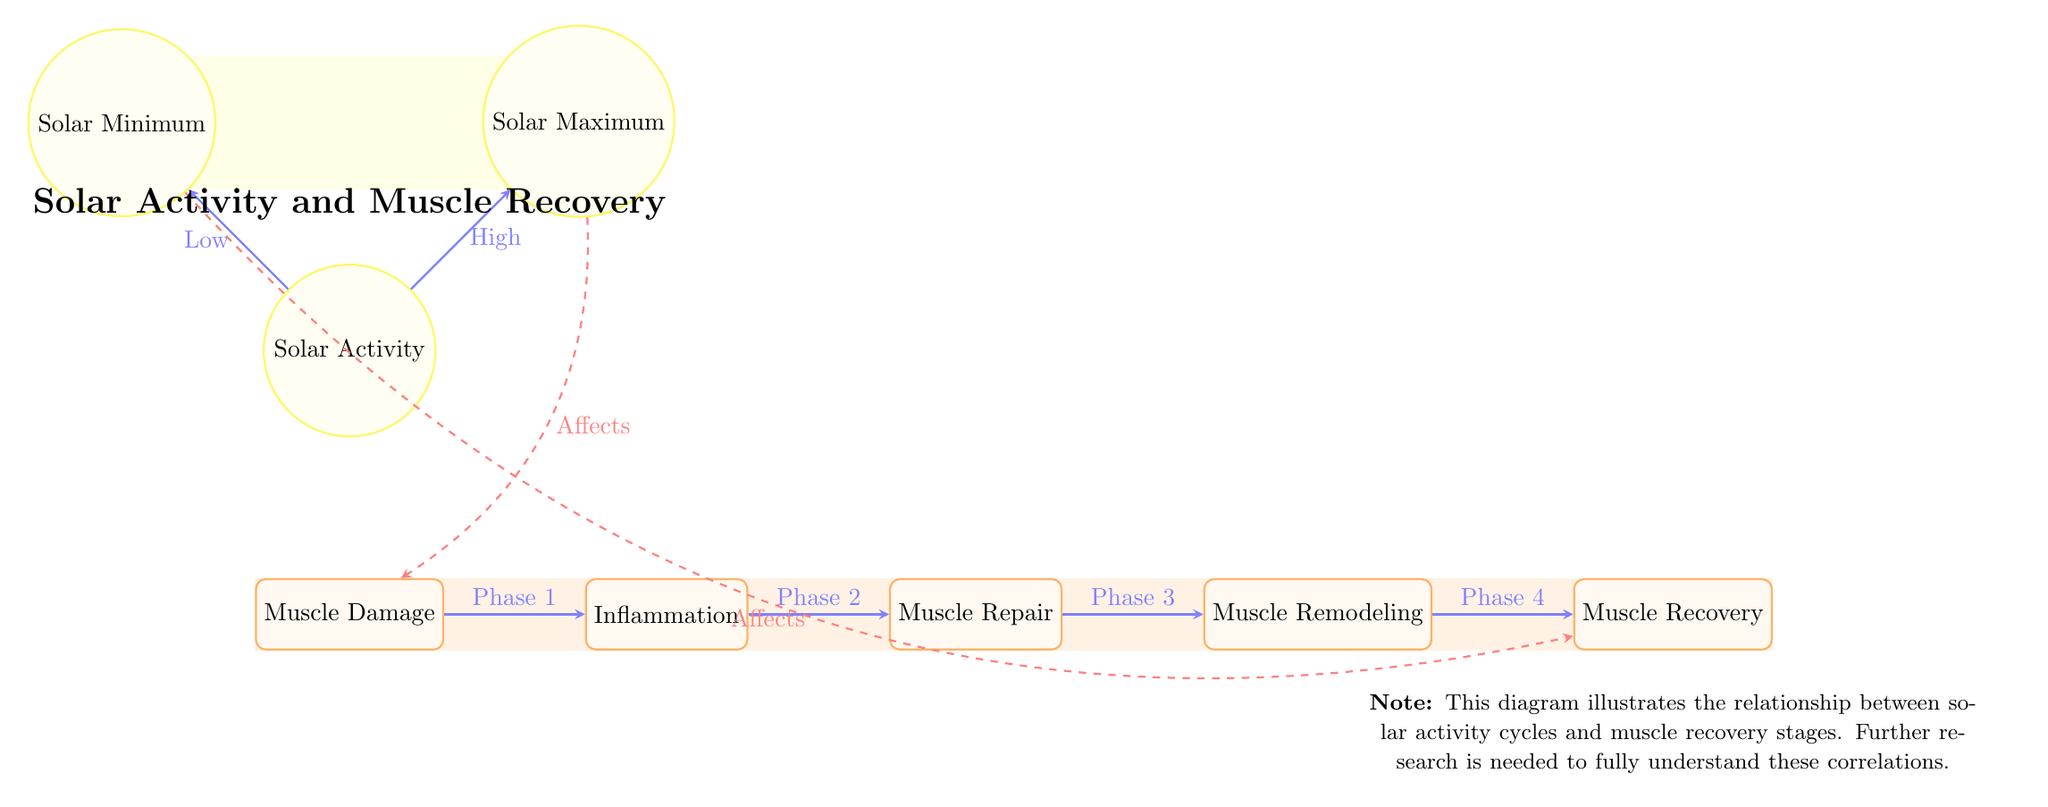What are the five stages of muscle recovery shown in the diagram? The diagram lists five stages: Muscle Damage, Inflammation, Muscle Repair, Muscle Remodeling, and Muscle Recovery. These stages are displayed sequentially from left to right.
Answer: Muscle Damage, Inflammation, Muscle Repair, Muscle Remodeling, Muscle Recovery What phase comes after Inflammation? The diagram indicates that after the Inflammation phase, the next stage is Muscle Repair, as connected by the arrow labeled "Phase 2."
Answer: Muscle Repair How many phases are indicated in the muscle recovery section? The muscle recovery section is described through five phases, as visualized by the arrows connecting each labeled node.
Answer: Five Which solar activity condition affects muscle recovery? The diagram shows that during Solar Minimum, it affects Muscle Recovery, as indicated by the arrow labeled "Affects."
Answer: Solar Minimum What is the relationship between Solar Maximum and Muscle Damage? The diagram illustrates that Solar Maximum affects Muscle Damage, with an arrow connecting the two nodes labeled "Affects."
Answer: Affects During which solar activity condition is muscle inflammation affected? The diagram does not explicitly state that muscle inflammation is affected by either solar activity condition; however, the flow suggests it is related to Solar Maximum, as it affects the initial stages.
Answer: Solar Maximum What type of arrows connect the muscle recovery stages? The arrows connecting the muscle recovery stages are categorized as "phase" arrows, indicating a sequential connection between the stages.
Answer: Phase Which stages are highlighted with specific colors in the background? The background fills for the muscle recovery stages use orange and for the solar activity conditions use yellow, differentiating the two categories visually.
Answer: Orange and yellow 